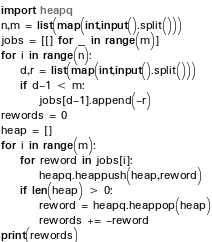Convert code to text. <code><loc_0><loc_0><loc_500><loc_500><_Python_>import heapq
n,m = list(map(int,input().split()))
jobs = [[] for _ in range(m)]
for i in range(n):
    d,r = list(map(int,input().split()))
    if d-1 < m:
        jobs[d-1].append(-r)
rewords = 0
heap = []
for i in range(m):
    for reword in jobs[i]:
        heapq.heappush(heap,reword)
    if len(heap) > 0:
        reword = heapq.heappop(heap)
        rewords += -reword
print(rewords)</code> 